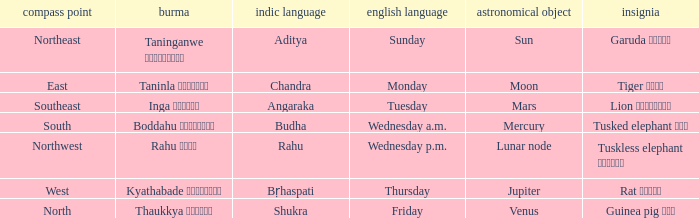What is the Burmese term for Thursday? Kyathabade ကြာသပတေး. 